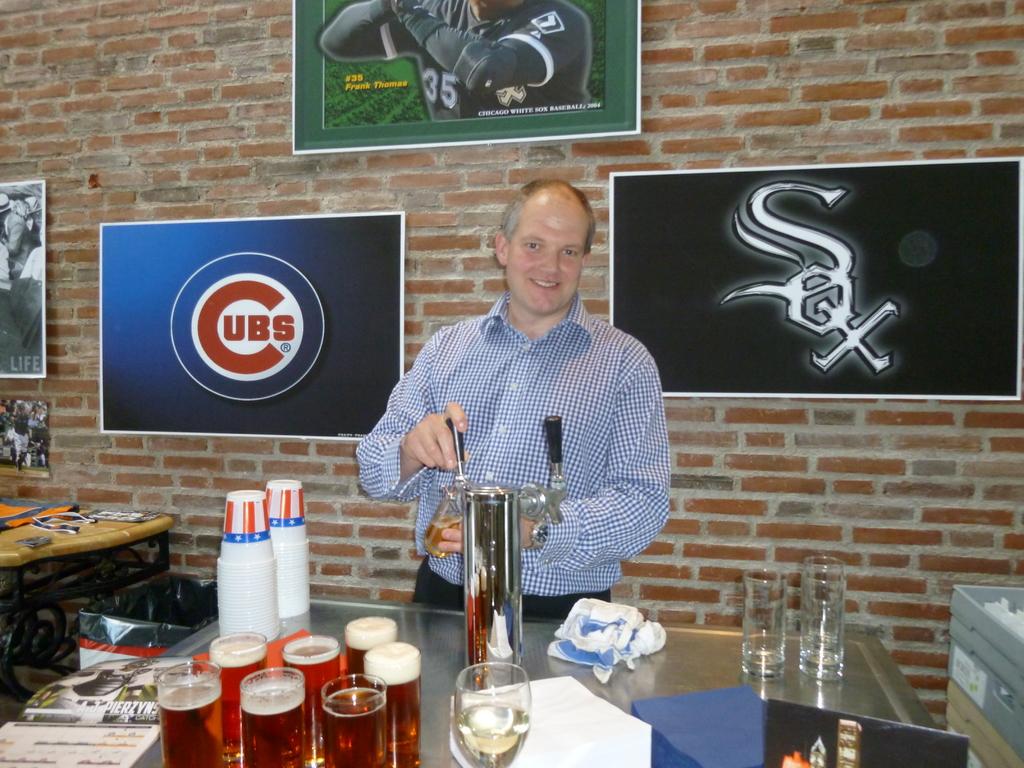Who is the player seen on the top poster?
Your response must be concise. Frank thomas. 